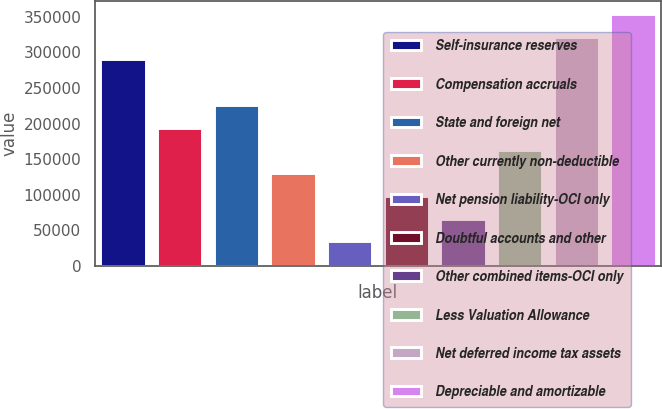Convert chart. <chart><loc_0><loc_0><loc_500><loc_500><bar_chart><fcel>Self-insurance reserves<fcel>Compensation accruals<fcel>State and foreign net<fcel>Other currently non-deductible<fcel>Net pension liability-OCI only<fcel>Doubtful accounts and other<fcel>Other combined items-OCI only<fcel>Less Valuation Allowance<fcel>Net deferred income tax assets<fcel>Depreciable and amortizable<nl><fcel>290318<fcel>194322<fcel>226321<fcel>130324<fcel>34327.8<fcel>98325.4<fcel>66326.6<fcel>162323<fcel>322317<fcel>354316<nl></chart> 